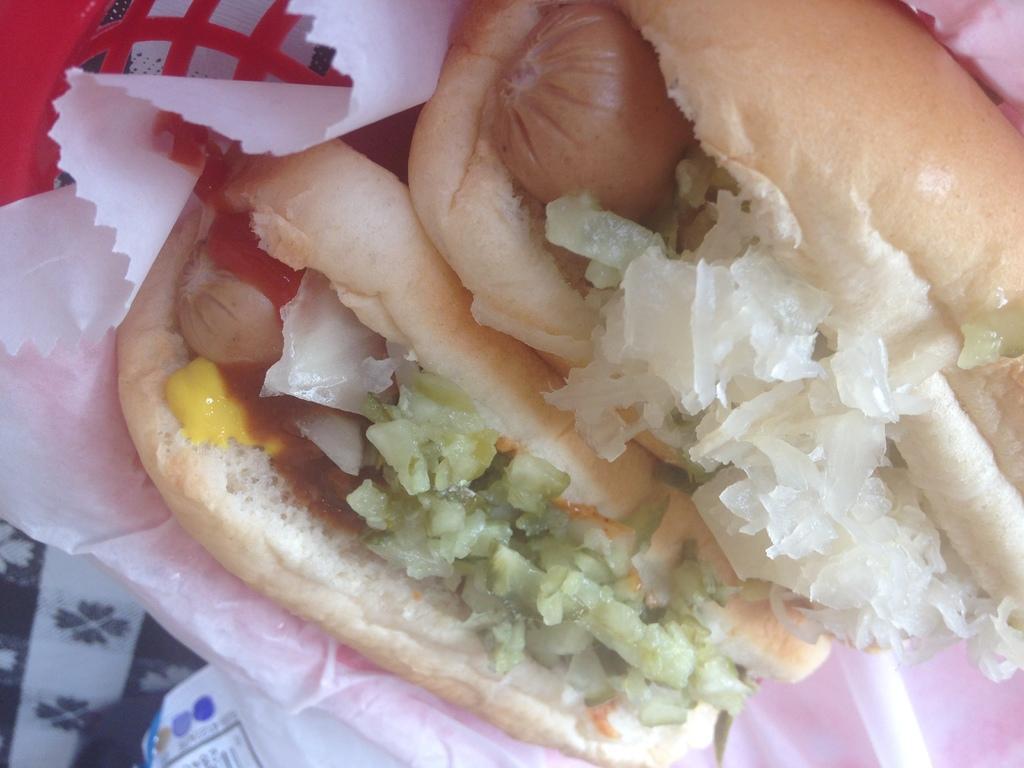In one or two sentences, can you explain what this image depicts? In this image we can see a food item on the paper, there is a red color object and a cloth. 